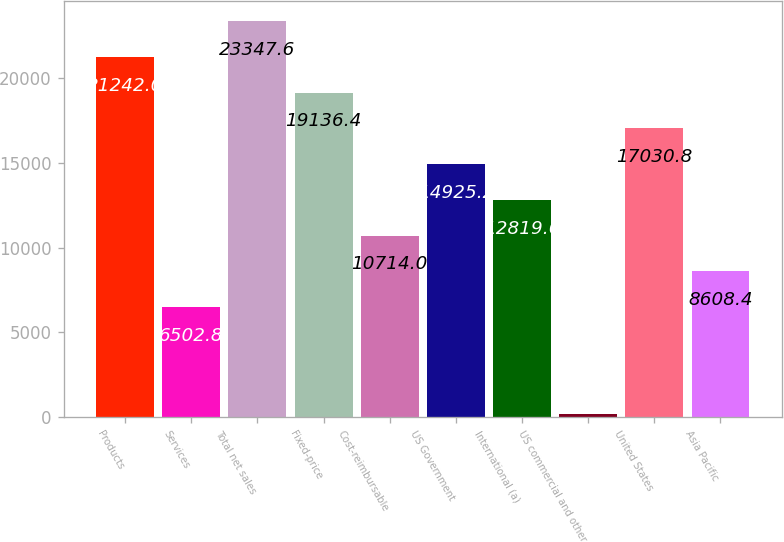<chart> <loc_0><loc_0><loc_500><loc_500><bar_chart><fcel>Products<fcel>Services<fcel>Total net sales<fcel>Fixed-price<fcel>Cost-reimbursable<fcel>US Government<fcel>International (a)<fcel>US commercial and other<fcel>United States<fcel>Asia Pacific<nl><fcel>21242<fcel>6502.8<fcel>23347.6<fcel>19136.4<fcel>10714<fcel>14925.2<fcel>12819.6<fcel>186<fcel>17030.8<fcel>8608.4<nl></chart> 